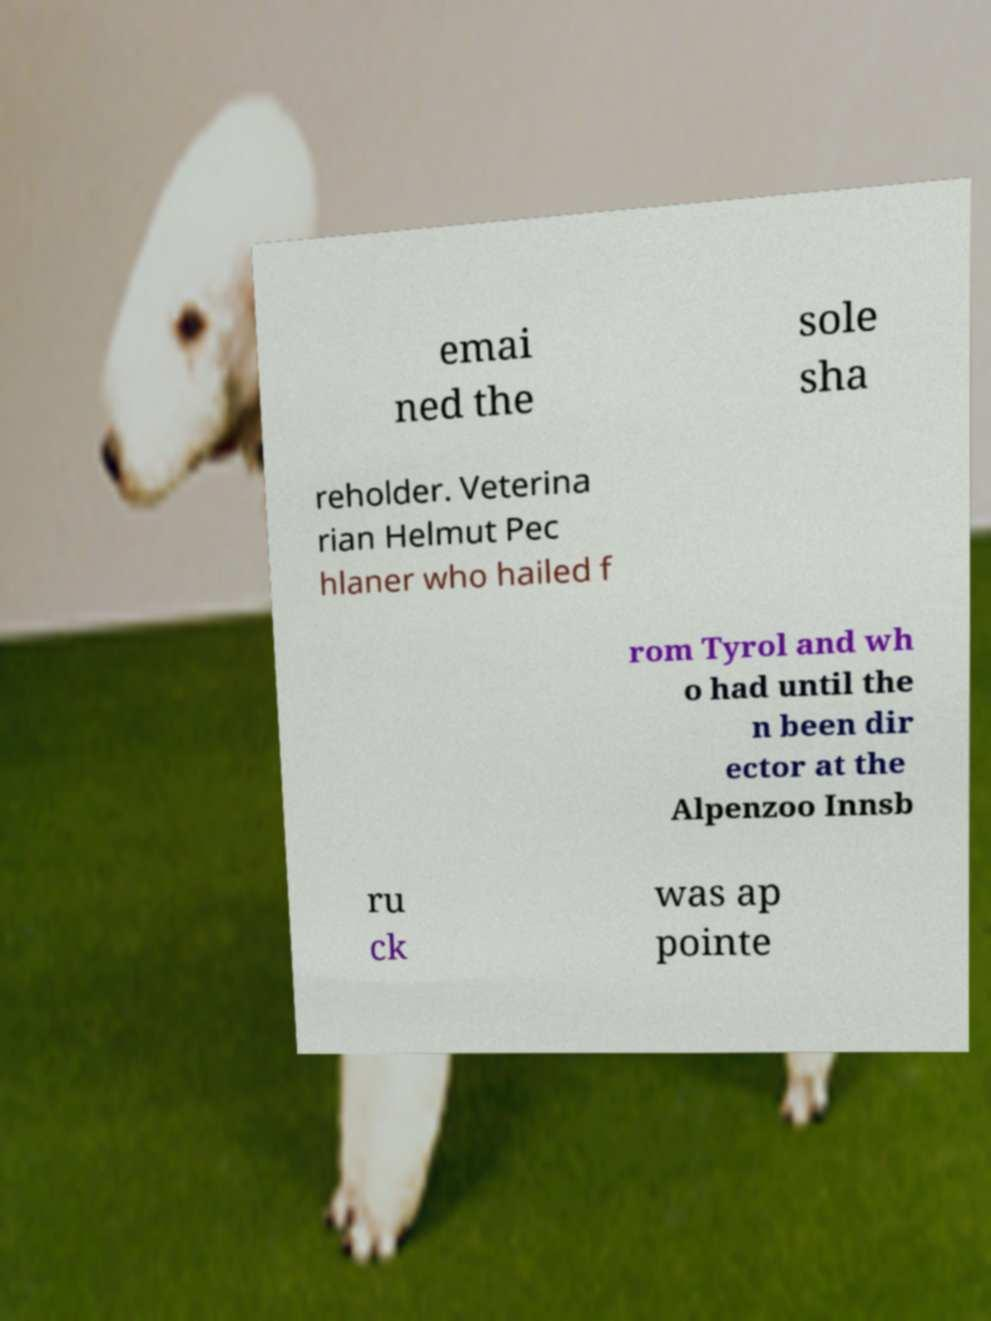Please read and relay the text visible in this image. What does it say? emai ned the sole sha reholder. Veterina rian Helmut Pec hlaner who hailed f rom Tyrol and wh o had until the n been dir ector at the Alpenzoo Innsb ru ck was ap pointe 